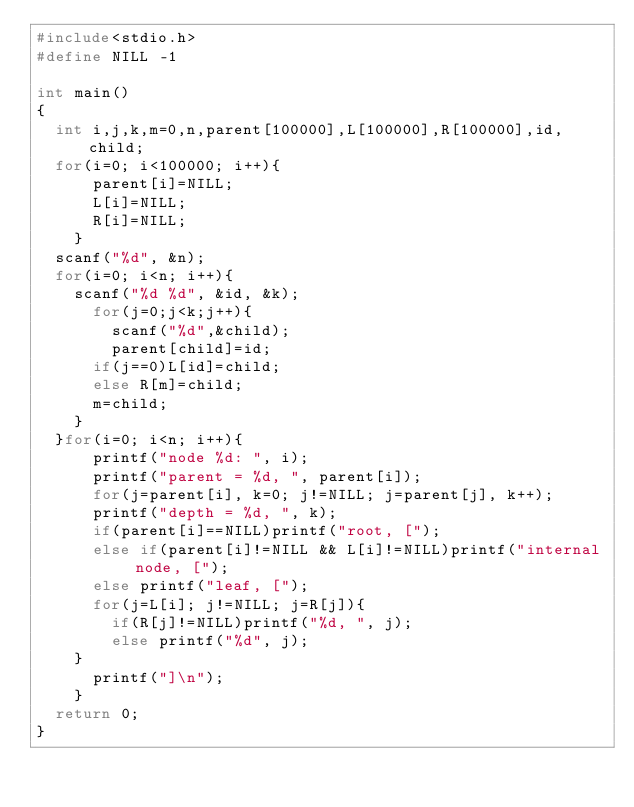Convert code to text. <code><loc_0><loc_0><loc_500><loc_500><_C_>#include<stdio.h>
#define NILL -1

int main()
{
  int i,j,k,m=0,n,parent[100000],L[100000],R[100000],id, child; 
  for(i=0; i<100000; i++){
      parent[i]=NILL;
      L[i]=NILL;
      R[i]=NILL;
    }
  scanf("%d", &n);
  for(i=0; i<n; i++){
    scanf("%d %d", &id, &k);
      for(j=0;j<k;j++){
        scanf("%d",&child);
        parent[child]=id;
	  if(j==0)L[id]=child;
	  else R[m]=child;
	  m=child;
    }
  }for(i=0; i<n; i++){
      printf("node %d: ", i);
      printf("parent = %d, ", parent[i]);
      for(j=parent[i], k=0; j!=NILL; j=parent[j], k++);
      printf("depth = %d, ", k);
      if(parent[i]==NILL)printf("root, [");
      else if(parent[i]!=NILL && L[i]!=NILL)printf("internal node, [");
      else printf("leaf, [");
      for(j=L[i]; j!=NILL; j=R[j]){
	    if(R[j]!=NILL)printf("%d, ", j);
	    else printf("%d", j);
	}
      printf("]\n");
    }
  return 0;
}
</code> 